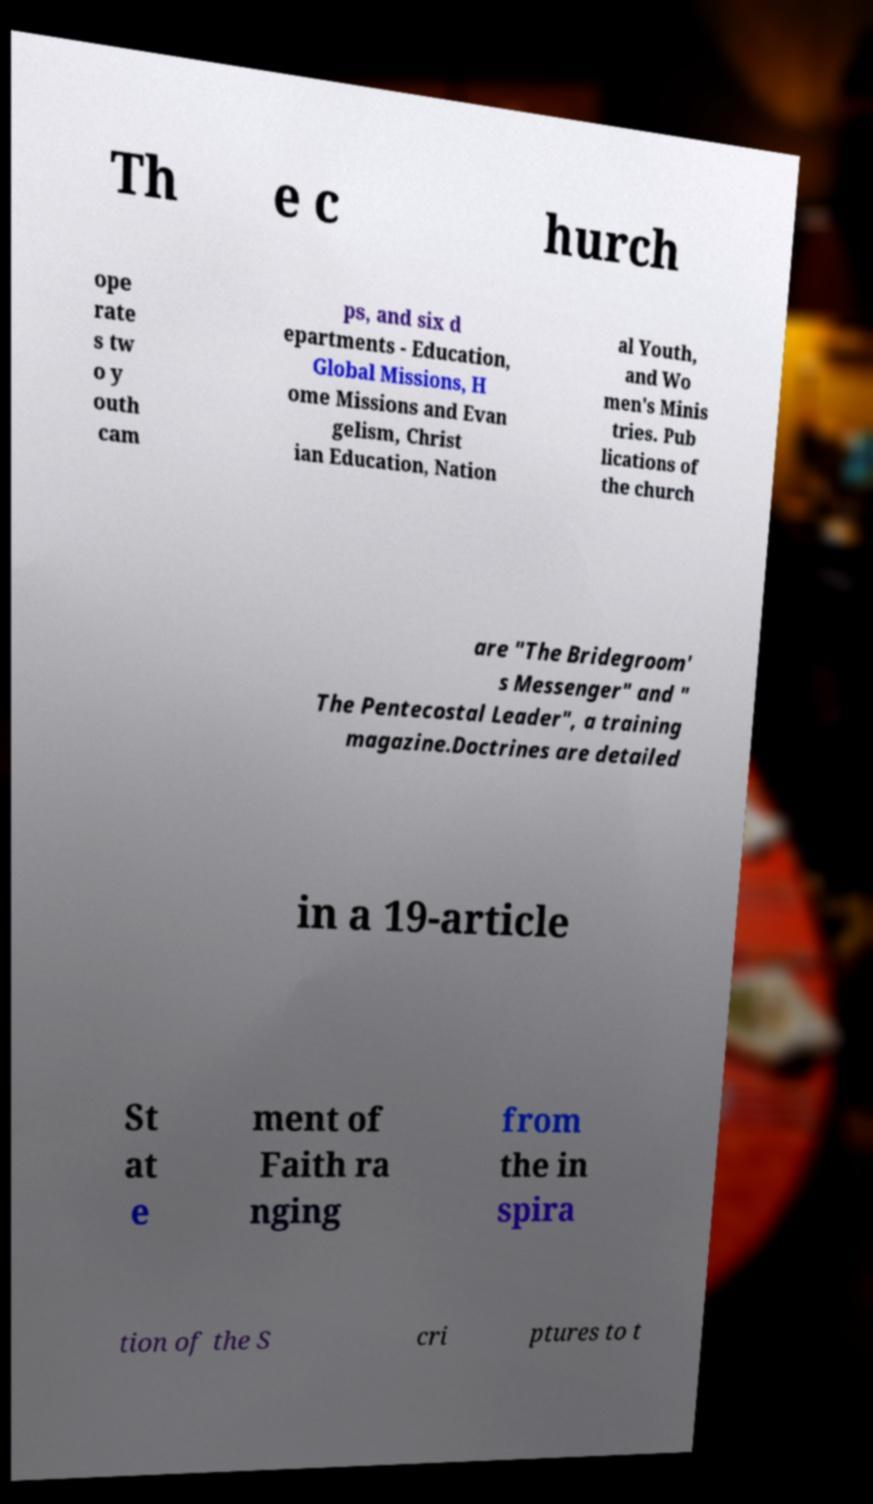Can you accurately transcribe the text from the provided image for me? Th e c hurch ope rate s tw o y outh cam ps, and six d epartments - Education, Global Missions, H ome Missions and Evan gelism, Christ ian Education, Nation al Youth, and Wo men's Minis tries. Pub lications of the church are "The Bridegroom' s Messenger" and " The Pentecostal Leader", a training magazine.Doctrines are detailed in a 19-article St at e ment of Faith ra nging from the in spira tion of the S cri ptures to t 